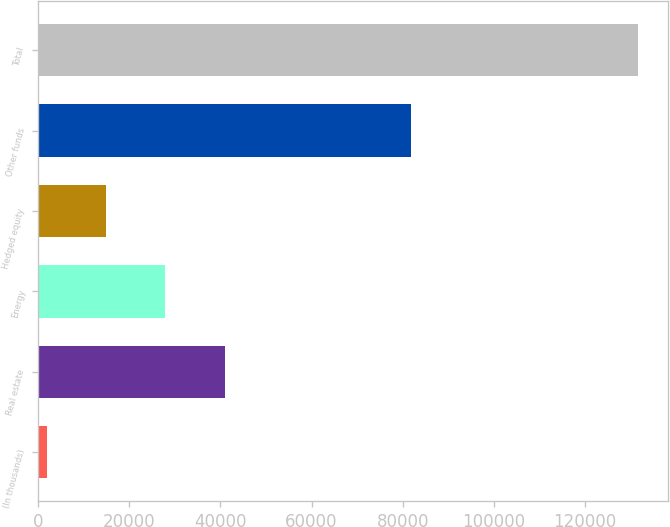Convert chart to OTSL. <chart><loc_0><loc_0><loc_500><loc_500><bar_chart><fcel>(In thousands)<fcel>Real estate<fcel>Energy<fcel>Hedged equity<fcel>Other funds<fcel>Total<nl><fcel>2014<fcel>40904.5<fcel>27941<fcel>14977.5<fcel>81859<fcel>131649<nl></chart> 